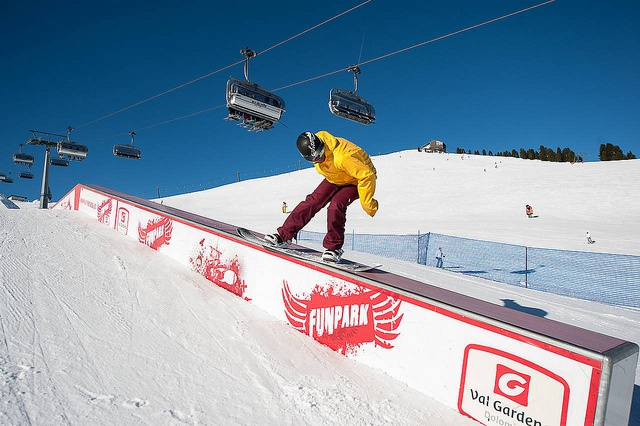Describe the objects in this image and their specific colors. I can see people in navy, maroon, black, orange, and olive tones, snowboard in navy, darkgray, lightgray, gray, and black tones, people in navy, lavender, darkgray, and blue tones, skis in navy, blue, and gray tones, and people in navy, white, gray, and darkgray tones in this image. 